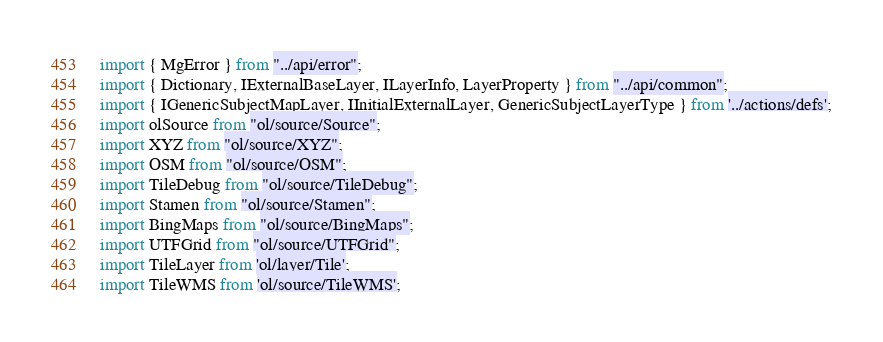<code> <loc_0><loc_0><loc_500><loc_500><_TypeScript_>import { MgError } from "../api/error";
import { Dictionary, IExternalBaseLayer, ILayerInfo, LayerProperty } from "../api/common";
import { IGenericSubjectMapLayer, IInitialExternalLayer, GenericSubjectLayerType } from '../actions/defs';
import olSource from "ol/source/Source";
import XYZ from "ol/source/XYZ";
import OSM from "ol/source/OSM";
import TileDebug from "ol/source/TileDebug";
import Stamen from "ol/source/Stamen";
import BingMaps from "ol/source/BingMaps";
import UTFGrid from "ol/source/UTFGrid";
import TileLayer from 'ol/layer/Tile';
import TileWMS from 'ol/source/TileWMS';</code> 